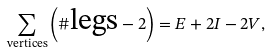Convert formula to latex. <formula><loc_0><loc_0><loc_500><loc_500>\sum _ { \text {vertices} } \left ( \# \text {legs} - 2 \right ) = E + 2 I - 2 V ,</formula> 